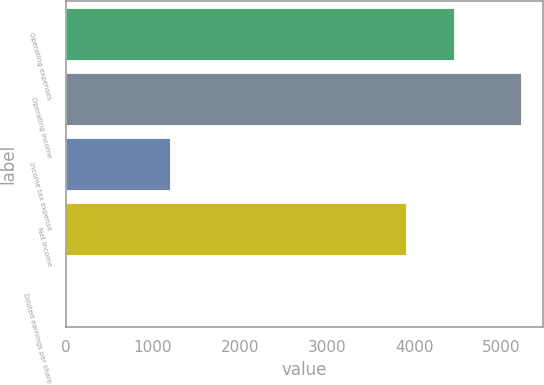Convert chart. <chart><loc_0><loc_0><loc_500><loc_500><bar_chart><fcel>Operating expenses<fcel>Operating income<fcel>Income tax expense<fcel>Net income<fcel>Diluted earnings per share<nl><fcel>4449<fcel>5218<fcel>1195<fcel>3903<fcel>3.43<nl></chart> 